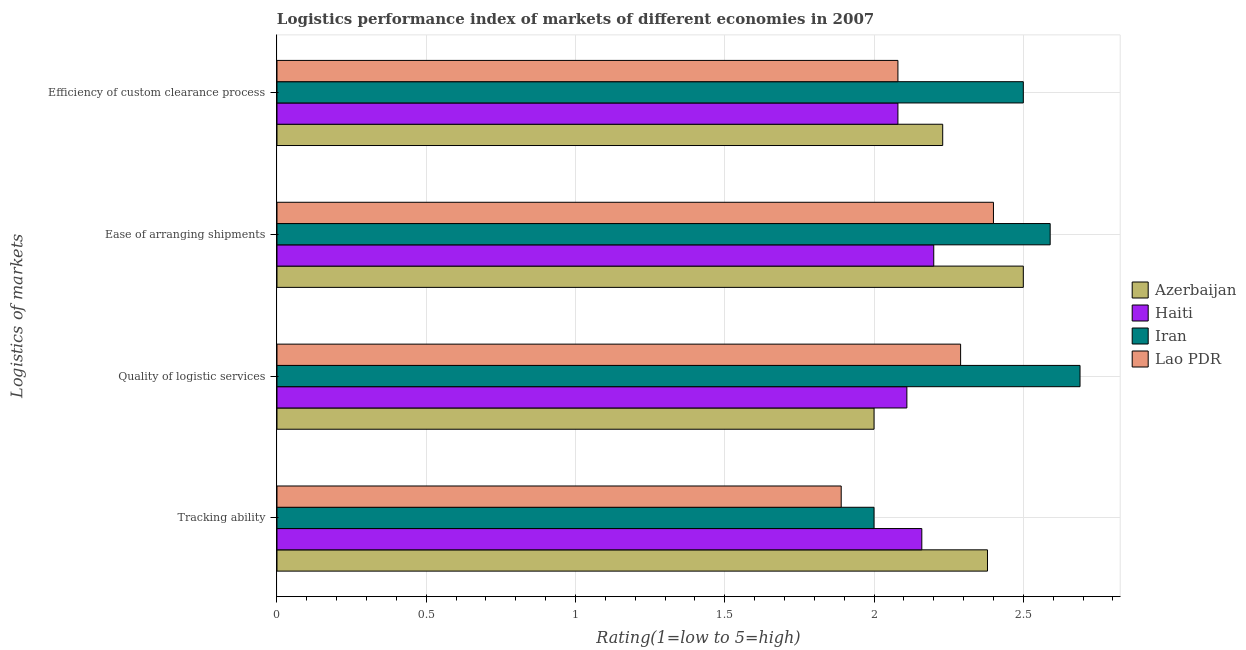Are the number of bars per tick equal to the number of legend labels?
Your answer should be very brief. Yes. How many bars are there on the 4th tick from the top?
Make the answer very short. 4. How many bars are there on the 3rd tick from the bottom?
Offer a terse response. 4. What is the label of the 4th group of bars from the top?
Provide a short and direct response. Tracking ability. What is the lpi rating of efficiency of custom clearance process in Haiti?
Your answer should be compact. 2.08. Across all countries, what is the maximum lpi rating of quality of logistic services?
Provide a succinct answer. 2.69. Across all countries, what is the minimum lpi rating of quality of logistic services?
Your answer should be very brief. 2. In which country was the lpi rating of ease of arranging shipments maximum?
Offer a very short reply. Iran. In which country was the lpi rating of efficiency of custom clearance process minimum?
Offer a very short reply. Haiti. What is the total lpi rating of tracking ability in the graph?
Your answer should be compact. 8.43. What is the difference between the lpi rating of quality of logistic services in Haiti and that in Lao PDR?
Your answer should be compact. -0.18. What is the difference between the lpi rating of quality of logistic services in Haiti and the lpi rating of tracking ability in Azerbaijan?
Make the answer very short. -0.27. What is the average lpi rating of efficiency of custom clearance process per country?
Your response must be concise. 2.22. What is the difference between the lpi rating of efficiency of custom clearance process and lpi rating of quality of logistic services in Haiti?
Your response must be concise. -0.03. What is the ratio of the lpi rating of ease of arranging shipments in Azerbaijan to that in Haiti?
Keep it short and to the point. 1.14. Is the lpi rating of ease of arranging shipments in Lao PDR less than that in Azerbaijan?
Your response must be concise. Yes. What is the difference between the highest and the second highest lpi rating of ease of arranging shipments?
Offer a terse response. 0.09. What is the difference between the highest and the lowest lpi rating of efficiency of custom clearance process?
Provide a short and direct response. 0.42. In how many countries, is the lpi rating of efficiency of custom clearance process greater than the average lpi rating of efficiency of custom clearance process taken over all countries?
Make the answer very short. 2. Is it the case that in every country, the sum of the lpi rating of efficiency of custom clearance process and lpi rating of tracking ability is greater than the sum of lpi rating of ease of arranging shipments and lpi rating of quality of logistic services?
Give a very brief answer. No. What does the 3rd bar from the top in Tracking ability represents?
Provide a succinct answer. Haiti. What does the 1st bar from the bottom in Efficiency of custom clearance process represents?
Keep it short and to the point. Azerbaijan. Are all the bars in the graph horizontal?
Ensure brevity in your answer.  Yes. Does the graph contain any zero values?
Your answer should be very brief. No. Does the graph contain grids?
Provide a succinct answer. Yes. How many legend labels are there?
Offer a very short reply. 4. How are the legend labels stacked?
Your answer should be very brief. Vertical. What is the title of the graph?
Make the answer very short. Logistics performance index of markets of different economies in 2007. Does "Pacific island small states" appear as one of the legend labels in the graph?
Make the answer very short. No. What is the label or title of the X-axis?
Your response must be concise. Rating(1=low to 5=high). What is the label or title of the Y-axis?
Your answer should be compact. Logistics of markets. What is the Rating(1=low to 5=high) in Azerbaijan in Tracking ability?
Your answer should be very brief. 2.38. What is the Rating(1=low to 5=high) in Haiti in Tracking ability?
Ensure brevity in your answer.  2.16. What is the Rating(1=low to 5=high) of Lao PDR in Tracking ability?
Your answer should be compact. 1.89. What is the Rating(1=low to 5=high) of Haiti in Quality of logistic services?
Your answer should be compact. 2.11. What is the Rating(1=low to 5=high) of Iran in Quality of logistic services?
Provide a short and direct response. 2.69. What is the Rating(1=low to 5=high) in Lao PDR in Quality of logistic services?
Offer a terse response. 2.29. What is the Rating(1=low to 5=high) in Haiti in Ease of arranging shipments?
Provide a succinct answer. 2.2. What is the Rating(1=low to 5=high) of Iran in Ease of arranging shipments?
Give a very brief answer. 2.59. What is the Rating(1=low to 5=high) in Lao PDR in Ease of arranging shipments?
Ensure brevity in your answer.  2.4. What is the Rating(1=low to 5=high) of Azerbaijan in Efficiency of custom clearance process?
Give a very brief answer. 2.23. What is the Rating(1=low to 5=high) of Haiti in Efficiency of custom clearance process?
Offer a very short reply. 2.08. What is the Rating(1=low to 5=high) of Lao PDR in Efficiency of custom clearance process?
Ensure brevity in your answer.  2.08. Across all Logistics of markets, what is the maximum Rating(1=low to 5=high) in Azerbaijan?
Your answer should be very brief. 2.5. Across all Logistics of markets, what is the maximum Rating(1=low to 5=high) in Haiti?
Ensure brevity in your answer.  2.2. Across all Logistics of markets, what is the maximum Rating(1=low to 5=high) of Iran?
Provide a short and direct response. 2.69. Across all Logistics of markets, what is the maximum Rating(1=low to 5=high) of Lao PDR?
Your answer should be compact. 2.4. Across all Logistics of markets, what is the minimum Rating(1=low to 5=high) in Haiti?
Ensure brevity in your answer.  2.08. Across all Logistics of markets, what is the minimum Rating(1=low to 5=high) of Lao PDR?
Provide a succinct answer. 1.89. What is the total Rating(1=low to 5=high) of Azerbaijan in the graph?
Your answer should be compact. 9.11. What is the total Rating(1=low to 5=high) in Haiti in the graph?
Your response must be concise. 8.55. What is the total Rating(1=low to 5=high) in Iran in the graph?
Keep it short and to the point. 9.78. What is the total Rating(1=low to 5=high) of Lao PDR in the graph?
Give a very brief answer. 8.66. What is the difference between the Rating(1=low to 5=high) of Azerbaijan in Tracking ability and that in Quality of logistic services?
Offer a terse response. 0.38. What is the difference between the Rating(1=low to 5=high) of Haiti in Tracking ability and that in Quality of logistic services?
Your response must be concise. 0.05. What is the difference between the Rating(1=low to 5=high) of Iran in Tracking ability and that in Quality of logistic services?
Provide a succinct answer. -0.69. What is the difference between the Rating(1=low to 5=high) of Lao PDR in Tracking ability and that in Quality of logistic services?
Provide a succinct answer. -0.4. What is the difference between the Rating(1=low to 5=high) in Azerbaijan in Tracking ability and that in Ease of arranging shipments?
Your response must be concise. -0.12. What is the difference between the Rating(1=low to 5=high) of Haiti in Tracking ability and that in Ease of arranging shipments?
Keep it short and to the point. -0.04. What is the difference between the Rating(1=low to 5=high) in Iran in Tracking ability and that in Ease of arranging shipments?
Provide a succinct answer. -0.59. What is the difference between the Rating(1=low to 5=high) of Lao PDR in Tracking ability and that in Ease of arranging shipments?
Ensure brevity in your answer.  -0.51. What is the difference between the Rating(1=low to 5=high) in Azerbaijan in Tracking ability and that in Efficiency of custom clearance process?
Make the answer very short. 0.15. What is the difference between the Rating(1=low to 5=high) of Iran in Tracking ability and that in Efficiency of custom clearance process?
Keep it short and to the point. -0.5. What is the difference between the Rating(1=low to 5=high) of Lao PDR in Tracking ability and that in Efficiency of custom clearance process?
Your response must be concise. -0.19. What is the difference between the Rating(1=low to 5=high) of Azerbaijan in Quality of logistic services and that in Ease of arranging shipments?
Keep it short and to the point. -0.5. What is the difference between the Rating(1=low to 5=high) in Haiti in Quality of logistic services and that in Ease of arranging shipments?
Offer a very short reply. -0.09. What is the difference between the Rating(1=low to 5=high) in Iran in Quality of logistic services and that in Ease of arranging shipments?
Offer a very short reply. 0.1. What is the difference between the Rating(1=low to 5=high) in Lao PDR in Quality of logistic services and that in Ease of arranging shipments?
Provide a short and direct response. -0.11. What is the difference between the Rating(1=low to 5=high) in Azerbaijan in Quality of logistic services and that in Efficiency of custom clearance process?
Offer a terse response. -0.23. What is the difference between the Rating(1=low to 5=high) in Iran in Quality of logistic services and that in Efficiency of custom clearance process?
Provide a succinct answer. 0.19. What is the difference between the Rating(1=low to 5=high) of Lao PDR in Quality of logistic services and that in Efficiency of custom clearance process?
Your response must be concise. 0.21. What is the difference between the Rating(1=low to 5=high) of Azerbaijan in Ease of arranging shipments and that in Efficiency of custom clearance process?
Provide a succinct answer. 0.27. What is the difference between the Rating(1=low to 5=high) of Haiti in Ease of arranging shipments and that in Efficiency of custom clearance process?
Your answer should be very brief. 0.12. What is the difference between the Rating(1=low to 5=high) in Iran in Ease of arranging shipments and that in Efficiency of custom clearance process?
Make the answer very short. 0.09. What is the difference between the Rating(1=low to 5=high) in Lao PDR in Ease of arranging shipments and that in Efficiency of custom clearance process?
Make the answer very short. 0.32. What is the difference between the Rating(1=low to 5=high) in Azerbaijan in Tracking ability and the Rating(1=low to 5=high) in Haiti in Quality of logistic services?
Your response must be concise. 0.27. What is the difference between the Rating(1=low to 5=high) in Azerbaijan in Tracking ability and the Rating(1=low to 5=high) in Iran in Quality of logistic services?
Your answer should be very brief. -0.31. What is the difference between the Rating(1=low to 5=high) of Azerbaijan in Tracking ability and the Rating(1=low to 5=high) of Lao PDR in Quality of logistic services?
Offer a terse response. 0.09. What is the difference between the Rating(1=low to 5=high) of Haiti in Tracking ability and the Rating(1=low to 5=high) of Iran in Quality of logistic services?
Provide a succinct answer. -0.53. What is the difference between the Rating(1=low to 5=high) in Haiti in Tracking ability and the Rating(1=low to 5=high) in Lao PDR in Quality of logistic services?
Provide a short and direct response. -0.13. What is the difference between the Rating(1=low to 5=high) of Iran in Tracking ability and the Rating(1=low to 5=high) of Lao PDR in Quality of logistic services?
Make the answer very short. -0.29. What is the difference between the Rating(1=low to 5=high) of Azerbaijan in Tracking ability and the Rating(1=low to 5=high) of Haiti in Ease of arranging shipments?
Provide a short and direct response. 0.18. What is the difference between the Rating(1=low to 5=high) of Azerbaijan in Tracking ability and the Rating(1=low to 5=high) of Iran in Ease of arranging shipments?
Give a very brief answer. -0.21. What is the difference between the Rating(1=low to 5=high) of Azerbaijan in Tracking ability and the Rating(1=low to 5=high) of Lao PDR in Ease of arranging shipments?
Keep it short and to the point. -0.02. What is the difference between the Rating(1=low to 5=high) of Haiti in Tracking ability and the Rating(1=low to 5=high) of Iran in Ease of arranging shipments?
Your response must be concise. -0.43. What is the difference between the Rating(1=low to 5=high) in Haiti in Tracking ability and the Rating(1=low to 5=high) in Lao PDR in Ease of arranging shipments?
Keep it short and to the point. -0.24. What is the difference between the Rating(1=low to 5=high) in Iran in Tracking ability and the Rating(1=low to 5=high) in Lao PDR in Ease of arranging shipments?
Offer a terse response. -0.4. What is the difference between the Rating(1=low to 5=high) in Azerbaijan in Tracking ability and the Rating(1=low to 5=high) in Haiti in Efficiency of custom clearance process?
Your response must be concise. 0.3. What is the difference between the Rating(1=low to 5=high) of Azerbaijan in Tracking ability and the Rating(1=low to 5=high) of Iran in Efficiency of custom clearance process?
Your answer should be very brief. -0.12. What is the difference between the Rating(1=low to 5=high) of Azerbaijan in Tracking ability and the Rating(1=low to 5=high) of Lao PDR in Efficiency of custom clearance process?
Give a very brief answer. 0.3. What is the difference between the Rating(1=low to 5=high) in Haiti in Tracking ability and the Rating(1=low to 5=high) in Iran in Efficiency of custom clearance process?
Your response must be concise. -0.34. What is the difference between the Rating(1=low to 5=high) in Haiti in Tracking ability and the Rating(1=low to 5=high) in Lao PDR in Efficiency of custom clearance process?
Give a very brief answer. 0.08. What is the difference between the Rating(1=low to 5=high) of Iran in Tracking ability and the Rating(1=low to 5=high) of Lao PDR in Efficiency of custom clearance process?
Give a very brief answer. -0.08. What is the difference between the Rating(1=low to 5=high) in Azerbaijan in Quality of logistic services and the Rating(1=low to 5=high) in Iran in Ease of arranging shipments?
Your answer should be compact. -0.59. What is the difference between the Rating(1=low to 5=high) in Haiti in Quality of logistic services and the Rating(1=low to 5=high) in Iran in Ease of arranging shipments?
Offer a very short reply. -0.48. What is the difference between the Rating(1=low to 5=high) of Haiti in Quality of logistic services and the Rating(1=low to 5=high) of Lao PDR in Ease of arranging shipments?
Keep it short and to the point. -0.29. What is the difference between the Rating(1=low to 5=high) in Iran in Quality of logistic services and the Rating(1=low to 5=high) in Lao PDR in Ease of arranging shipments?
Your answer should be very brief. 0.29. What is the difference between the Rating(1=low to 5=high) of Azerbaijan in Quality of logistic services and the Rating(1=low to 5=high) of Haiti in Efficiency of custom clearance process?
Your response must be concise. -0.08. What is the difference between the Rating(1=low to 5=high) of Azerbaijan in Quality of logistic services and the Rating(1=low to 5=high) of Iran in Efficiency of custom clearance process?
Make the answer very short. -0.5. What is the difference between the Rating(1=low to 5=high) in Azerbaijan in Quality of logistic services and the Rating(1=low to 5=high) in Lao PDR in Efficiency of custom clearance process?
Give a very brief answer. -0.08. What is the difference between the Rating(1=low to 5=high) in Haiti in Quality of logistic services and the Rating(1=low to 5=high) in Iran in Efficiency of custom clearance process?
Keep it short and to the point. -0.39. What is the difference between the Rating(1=low to 5=high) of Haiti in Quality of logistic services and the Rating(1=low to 5=high) of Lao PDR in Efficiency of custom clearance process?
Ensure brevity in your answer.  0.03. What is the difference between the Rating(1=low to 5=high) in Iran in Quality of logistic services and the Rating(1=low to 5=high) in Lao PDR in Efficiency of custom clearance process?
Provide a short and direct response. 0.61. What is the difference between the Rating(1=low to 5=high) in Azerbaijan in Ease of arranging shipments and the Rating(1=low to 5=high) in Haiti in Efficiency of custom clearance process?
Offer a terse response. 0.42. What is the difference between the Rating(1=low to 5=high) in Azerbaijan in Ease of arranging shipments and the Rating(1=low to 5=high) in Lao PDR in Efficiency of custom clearance process?
Make the answer very short. 0.42. What is the difference between the Rating(1=low to 5=high) in Haiti in Ease of arranging shipments and the Rating(1=low to 5=high) in Lao PDR in Efficiency of custom clearance process?
Offer a terse response. 0.12. What is the difference between the Rating(1=low to 5=high) in Iran in Ease of arranging shipments and the Rating(1=low to 5=high) in Lao PDR in Efficiency of custom clearance process?
Provide a succinct answer. 0.51. What is the average Rating(1=low to 5=high) in Azerbaijan per Logistics of markets?
Offer a terse response. 2.28. What is the average Rating(1=low to 5=high) of Haiti per Logistics of markets?
Give a very brief answer. 2.14. What is the average Rating(1=low to 5=high) in Iran per Logistics of markets?
Keep it short and to the point. 2.44. What is the average Rating(1=low to 5=high) in Lao PDR per Logistics of markets?
Offer a terse response. 2.17. What is the difference between the Rating(1=low to 5=high) in Azerbaijan and Rating(1=low to 5=high) in Haiti in Tracking ability?
Provide a succinct answer. 0.22. What is the difference between the Rating(1=low to 5=high) of Azerbaijan and Rating(1=low to 5=high) of Iran in Tracking ability?
Your answer should be very brief. 0.38. What is the difference between the Rating(1=low to 5=high) of Azerbaijan and Rating(1=low to 5=high) of Lao PDR in Tracking ability?
Provide a short and direct response. 0.49. What is the difference between the Rating(1=low to 5=high) of Haiti and Rating(1=low to 5=high) of Iran in Tracking ability?
Your answer should be compact. 0.16. What is the difference between the Rating(1=low to 5=high) in Haiti and Rating(1=low to 5=high) in Lao PDR in Tracking ability?
Give a very brief answer. 0.27. What is the difference between the Rating(1=low to 5=high) in Iran and Rating(1=low to 5=high) in Lao PDR in Tracking ability?
Your answer should be compact. 0.11. What is the difference between the Rating(1=low to 5=high) of Azerbaijan and Rating(1=low to 5=high) of Haiti in Quality of logistic services?
Provide a short and direct response. -0.11. What is the difference between the Rating(1=low to 5=high) in Azerbaijan and Rating(1=low to 5=high) in Iran in Quality of logistic services?
Your response must be concise. -0.69. What is the difference between the Rating(1=low to 5=high) of Azerbaijan and Rating(1=low to 5=high) of Lao PDR in Quality of logistic services?
Provide a succinct answer. -0.29. What is the difference between the Rating(1=low to 5=high) in Haiti and Rating(1=low to 5=high) in Iran in Quality of logistic services?
Your answer should be very brief. -0.58. What is the difference between the Rating(1=low to 5=high) in Haiti and Rating(1=low to 5=high) in Lao PDR in Quality of logistic services?
Give a very brief answer. -0.18. What is the difference between the Rating(1=low to 5=high) of Iran and Rating(1=low to 5=high) of Lao PDR in Quality of logistic services?
Offer a terse response. 0.4. What is the difference between the Rating(1=low to 5=high) in Azerbaijan and Rating(1=low to 5=high) in Iran in Ease of arranging shipments?
Keep it short and to the point. -0.09. What is the difference between the Rating(1=low to 5=high) in Azerbaijan and Rating(1=low to 5=high) in Lao PDR in Ease of arranging shipments?
Your answer should be very brief. 0.1. What is the difference between the Rating(1=low to 5=high) of Haiti and Rating(1=low to 5=high) of Iran in Ease of arranging shipments?
Offer a terse response. -0.39. What is the difference between the Rating(1=low to 5=high) in Iran and Rating(1=low to 5=high) in Lao PDR in Ease of arranging shipments?
Offer a very short reply. 0.19. What is the difference between the Rating(1=low to 5=high) in Azerbaijan and Rating(1=low to 5=high) in Haiti in Efficiency of custom clearance process?
Make the answer very short. 0.15. What is the difference between the Rating(1=low to 5=high) of Azerbaijan and Rating(1=low to 5=high) of Iran in Efficiency of custom clearance process?
Offer a terse response. -0.27. What is the difference between the Rating(1=low to 5=high) in Haiti and Rating(1=low to 5=high) in Iran in Efficiency of custom clearance process?
Provide a succinct answer. -0.42. What is the difference between the Rating(1=low to 5=high) of Iran and Rating(1=low to 5=high) of Lao PDR in Efficiency of custom clearance process?
Your answer should be compact. 0.42. What is the ratio of the Rating(1=low to 5=high) of Azerbaijan in Tracking ability to that in Quality of logistic services?
Your response must be concise. 1.19. What is the ratio of the Rating(1=low to 5=high) in Haiti in Tracking ability to that in Quality of logistic services?
Your answer should be very brief. 1.02. What is the ratio of the Rating(1=low to 5=high) of Iran in Tracking ability to that in Quality of logistic services?
Your answer should be compact. 0.74. What is the ratio of the Rating(1=low to 5=high) of Lao PDR in Tracking ability to that in Quality of logistic services?
Offer a very short reply. 0.83. What is the ratio of the Rating(1=low to 5=high) of Azerbaijan in Tracking ability to that in Ease of arranging shipments?
Your answer should be compact. 0.95. What is the ratio of the Rating(1=low to 5=high) of Haiti in Tracking ability to that in Ease of arranging shipments?
Your answer should be compact. 0.98. What is the ratio of the Rating(1=low to 5=high) of Iran in Tracking ability to that in Ease of arranging shipments?
Keep it short and to the point. 0.77. What is the ratio of the Rating(1=low to 5=high) of Lao PDR in Tracking ability to that in Ease of arranging shipments?
Offer a very short reply. 0.79. What is the ratio of the Rating(1=low to 5=high) of Azerbaijan in Tracking ability to that in Efficiency of custom clearance process?
Your response must be concise. 1.07. What is the ratio of the Rating(1=low to 5=high) of Haiti in Tracking ability to that in Efficiency of custom clearance process?
Offer a very short reply. 1.04. What is the ratio of the Rating(1=low to 5=high) in Lao PDR in Tracking ability to that in Efficiency of custom clearance process?
Give a very brief answer. 0.91. What is the ratio of the Rating(1=low to 5=high) of Haiti in Quality of logistic services to that in Ease of arranging shipments?
Offer a very short reply. 0.96. What is the ratio of the Rating(1=low to 5=high) in Iran in Quality of logistic services to that in Ease of arranging shipments?
Offer a very short reply. 1.04. What is the ratio of the Rating(1=low to 5=high) in Lao PDR in Quality of logistic services to that in Ease of arranging shipments?
Provide a short and direct response. 0.95. What is the ratio of the Rating(1=low to 5=high) of Azerbaijan in Quality of logistic services to that in Efficiency of custom clearance process?
Your answer should be very brief. 0.9. What is the ratio of the Rating(1=low to 5=high) in Haiti in Quality of logistic services to that in Efficiency of custom clearance process?
Your response must be concise. 1.01. What is the ratio of the Rating(1=low to 5=high) of Iran in Quality of logistic services to that in Efficiency of custom clearance process?
Your answer should be very brief. 1.08. What is the ratio of the Rating(1=low to 5=high) of Lao PDR in Quality of logistic services to that in Efficiency of custom clearance process?
Provide a succinct answer. 1.1. What is the ratio of the Rating(1=low to 5=high) in Azerbaijan in Ease of arranging shipments to that in Efficiency of custom clearance process?
Keep it short and to the point. 1.12. What is the ratio of the Rating(1=low to 5=high) of Haiti in Ease of arranging shipments to that in Efficiency of custom clearance process?
Give a very brief answer. 1.06. What is the ratio of the Rating(1=low to 5=high) of Iran in Ease of arranging shipments to that in Efficiency of custom clearance process?
Ensure brevity in your answer.  1.04. What is the ratio of the Rating(1=low to 5=high) in Lao PDR in Ease of arranging shipments to that in Efficiency of custom clearance process?
Provide a short and direct response. 1.15. What is the difference between the highest and the second highest Rating(1=low to 5=high) in Azerbaijan?
Your response must be concise. 0.12. What is the difference between the highest and the second highest Rating(1=low to 5=high) in Haiti?
Keep it short and to the point. 0.04. What is the difference between the highest and the second highest Rating(1=low to 5=high) in Iran?
Provide a short and direct response. 0.1. What is the difference between the highest and the second highest Rating(1=low to 5=high) of Lao PDR?
Your response must be concise. 0.11. What is the difference between the highest and the lowest Rating(1=low to 5=high) in Haiti?
Offer a terse response. 0.12. What is the difference between the highest and the lowest Rating(1=low to 5=high) of Iran?
Your answer should be very brief. 0.69. What is the difference between the highest and the lowest Rating(1=low to 5=high) of Lao PDR?
Your response must be concise. 0.51. 